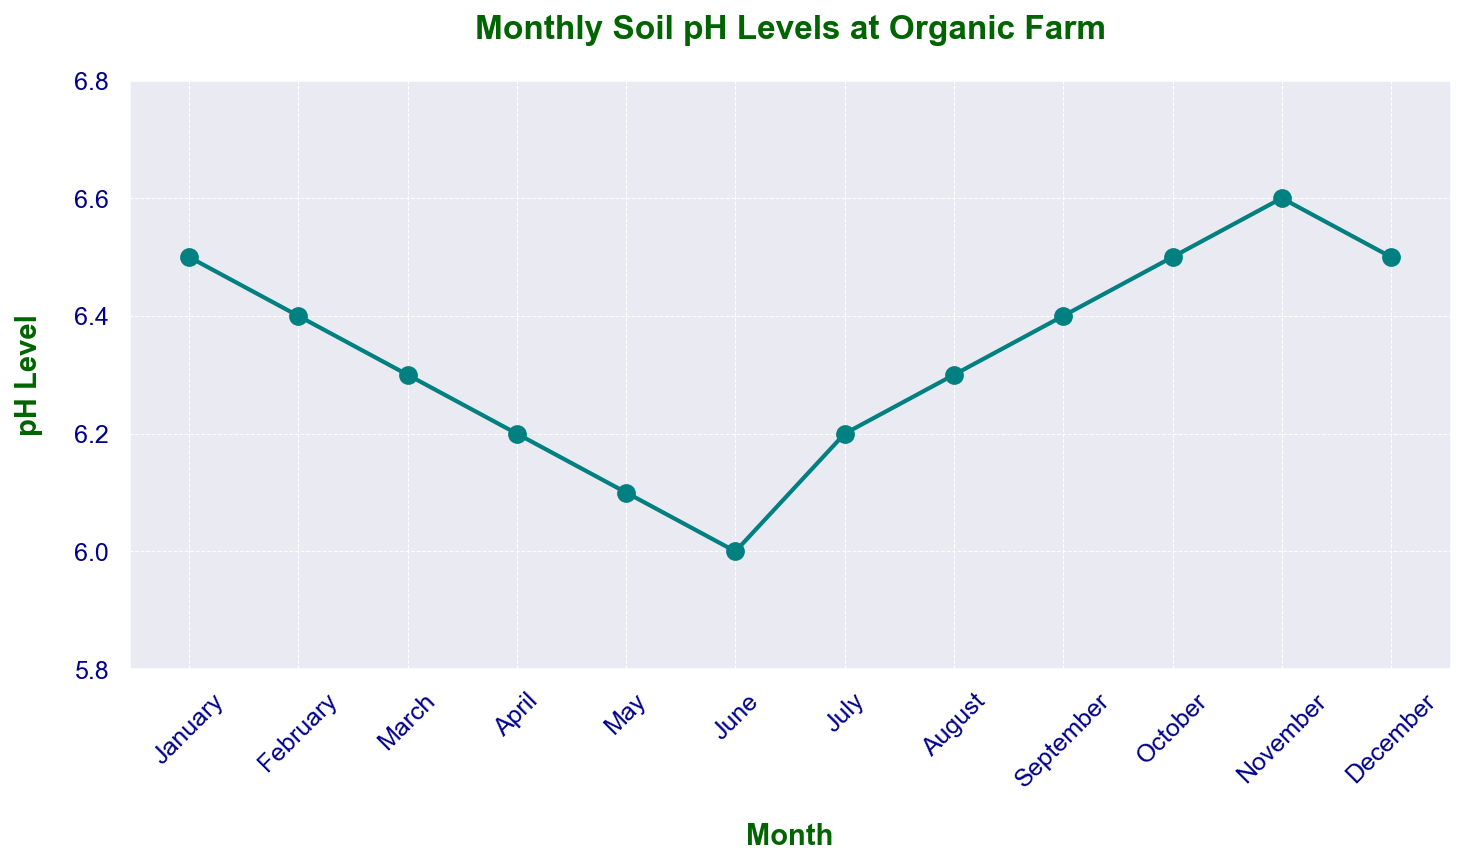What is the pH level in March? The pH level in March is directly shown on the chart by the data point for March.
Answer: 6.3 During which months does the soil pH level increase? Observing the chart, the soil pH level increases from June to July, from July to August, from August to September, and from October to November.
Answer: July, August, September, November How does the soil pH level in June compare to the soil pH level in November? Refer to the points on the graph for June and November. The pH level in June is 6.0, while in November it is 6.6, indicating a significant increase.
Answer: November is higher than June Which month shows the lowest soil pH level? By checking the lowest point on the graph, it is observed that June has the lowest pH level.
Answer: June What is the average soil pH level over the year? Sum all the pH levels from each month and divide by the number of months. (6.5 + 6.4 + 6.3 + 6.2 + 6.1 + 6.0 + 6.2 + 6.3 + 6.4 + 6.5 + 6.6 + 6.5)/12 = 6.35
Answer: 6.35 Between which two consecutive months is the largest pH level increase observed? Calculate the differences between each pair of consecutive months, the largest increase is between June and July (6.2 - 6.0 = 0.2), as well as between October and November (6.6 - 6.5 = 0.1).
Answer: June to July Is there a month when the soil pH level is exactly neutral, i.e., 7? Neutral pH level is 7. Observing the chart, there isn't any month where the pH level matches exactly 7.
Answer: No What is the range of the soil pH levels in the year? The range is found by subtracting the lowest from the highest value on the chart. The highest value is 6.6 (November) and the lowest is 6.0 (June). So, 6.6 - 6.0 = 0.6.
Answer: 0.6 